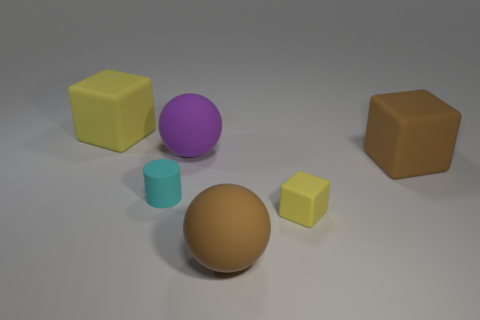Subtract all big brown cubes. How many cubes are left? 2 Subtract all blue balls. How many yellow blocks are left? 2 Add 4 big brown rubber things. How many objects exist? 10 Subtract 1 blocks. How many blocks are left? 2 Subtract all big yellow balls. Subtract all brown spheres. How many objects are left? 5 Add 2 tiny blocks. How many tiny blocks are left? 3 Add 5 small gray shiny spheres. How many small gray shiny spheres exist? 5 Subtract 0 gray cylinders. How many objects are left? 6 Subtract all spheres. How many objects are left? 4 Subtract all purple spheres. Subtract all brown cylinders. How many spheres are left? 1 